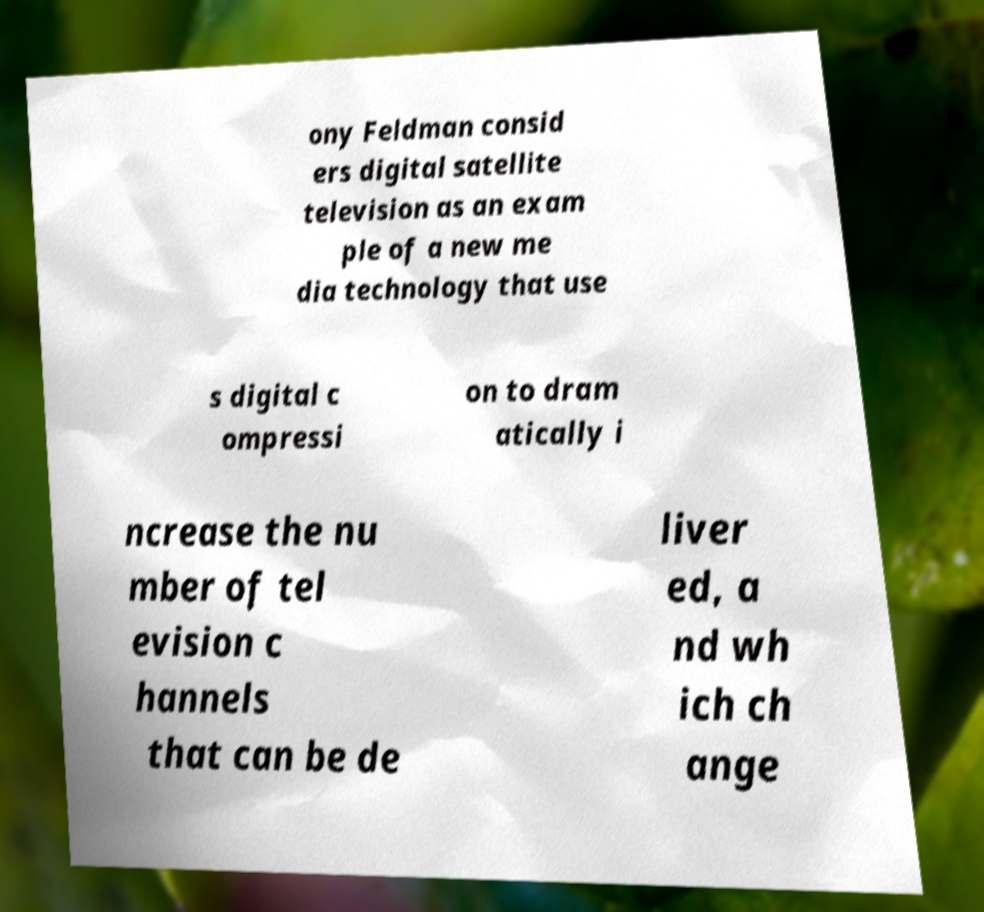For documentation purposes, I need the text within this image transcribed. Could you provide that? ony Feldman consid ers digital satellite television as an exam ple of a new me dia technology that use s digital c ompressi on to dram atically i ncrease the nu mber of tel evision c hannels that can be de liver ed, a nd wh ich ch ange 